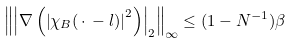<formula> <loc_0><loc_0><loc_500><loc_500>\left \| \left | \nabla \left ( \left | \chi _ { B } ( \, \cdot \, - l ) \right | ^ { 2 } \right ) \right | _ { 2 } \right \| _ { \infty } \leq ( 1 - N ^ { - 1 } ) \beta</formula> 